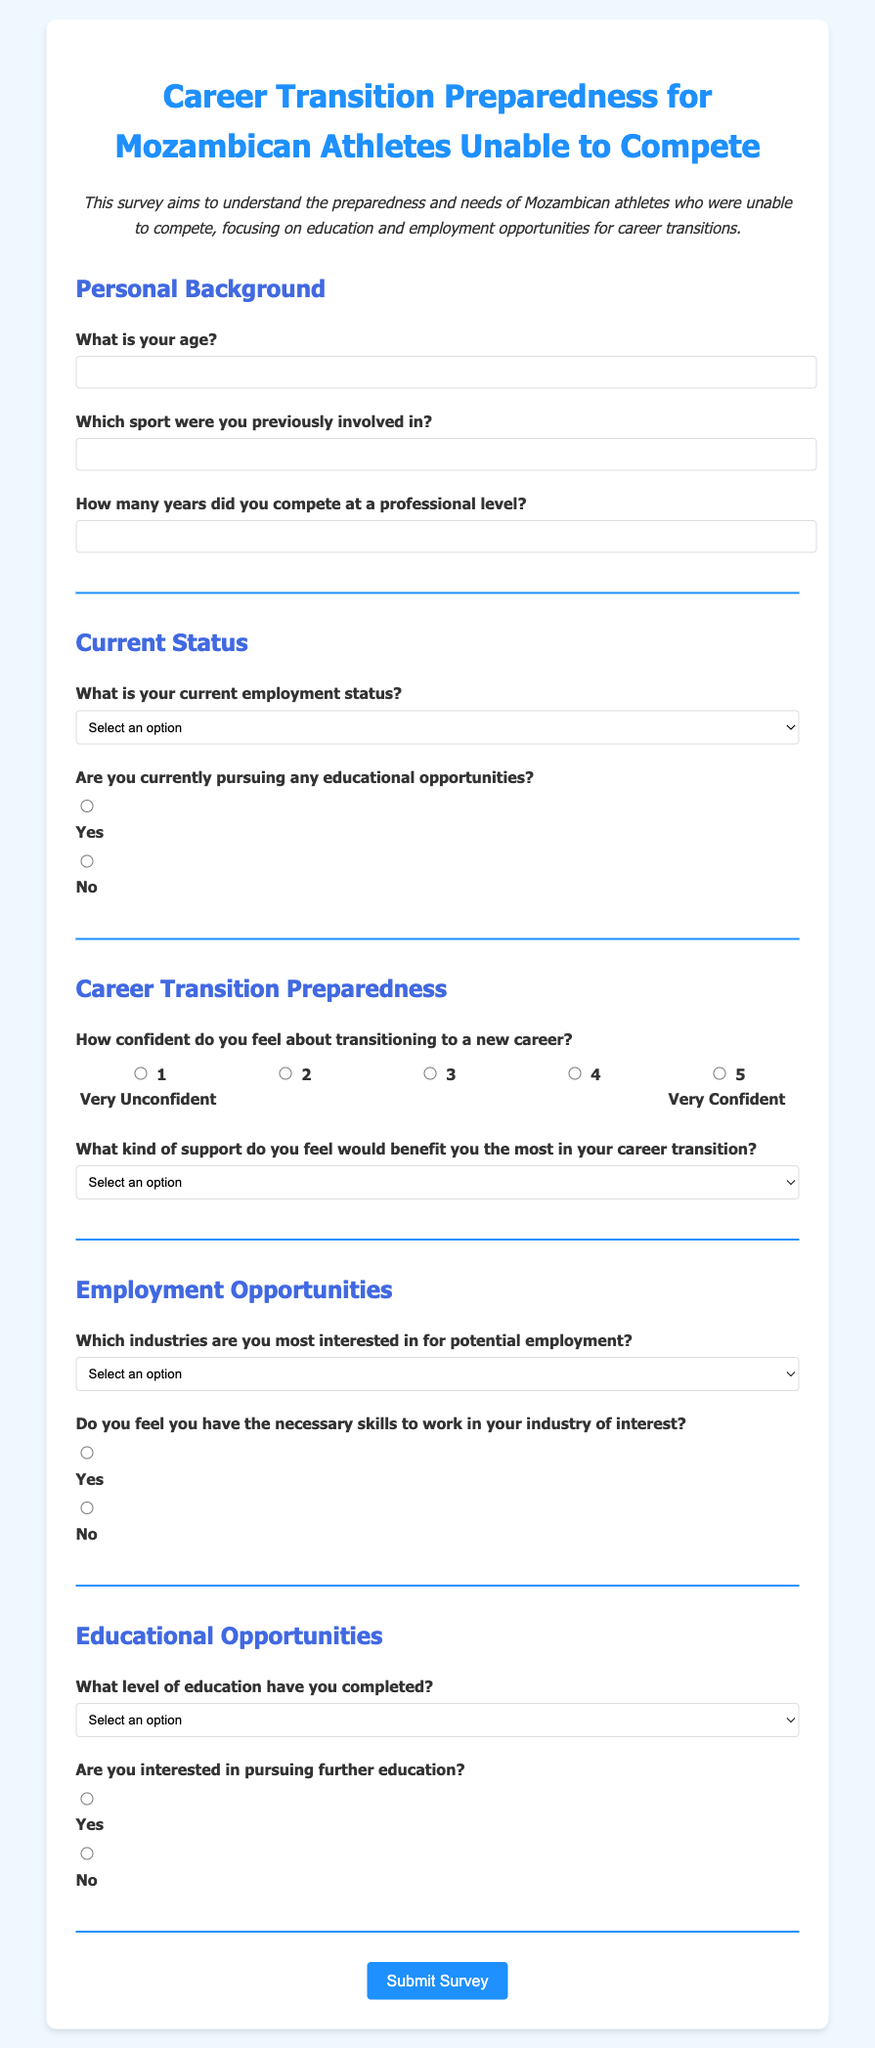What is the title of the survey? The title of the survey is stated at the top of the document, indicating its purpose and target audience.
Answer: Career Transition Preparedness for Mozambican Athletes Unable to Compete What is the maximum age that respondents can enter in the age field? The input field for age allows respondents to enter a numeric value, but no specific maximum is set in the document.
Answer: Not specified What type of support does the survey suggest would benefit athletes the most? The options provided in the support-type question give insight into the perceived needs of athletes for their career transitions.
Answer: Career counseling Which sport can respondents specify as their previous involvement? The document includes a question asking participants to identify the sport they were involved in, allowing for a range of answers.
Answer: Any sport (depends on individual response) How confident do respondents feel about transitioning to a new career on a scale of 1 to 5? The survey utilizes a radio button scale from 1 (Very Unconfident) to 5 (Very Confident) to gauge the respondents' confidence levels in career transition.
Answer: 1 to 5 (depends on individual response) Which industry is listed as an option for potential employment? The survey asks athletes to indicate their interest in various industries, presenting specific options.
Answer: Technology What level of education can respondents select in the education level question? Participants are prompted to indicate their highest completed level of education from several listed options.
Answer: High School Are respondents asked if they are interested in pursuing further education? A question specifically addresses the interest of athletes in further educational pursuits to understand their educational aspirations.
Answer: Yes or No What type of programs may respondents be interested in if they seek further education? The survey allows athletes to indicate types of educational programs they are interested in, which could include specific categories.
Answer: Vocational training, Certificate programs, Undergraduate degrees, Graduate degrees (depends on individual response) 